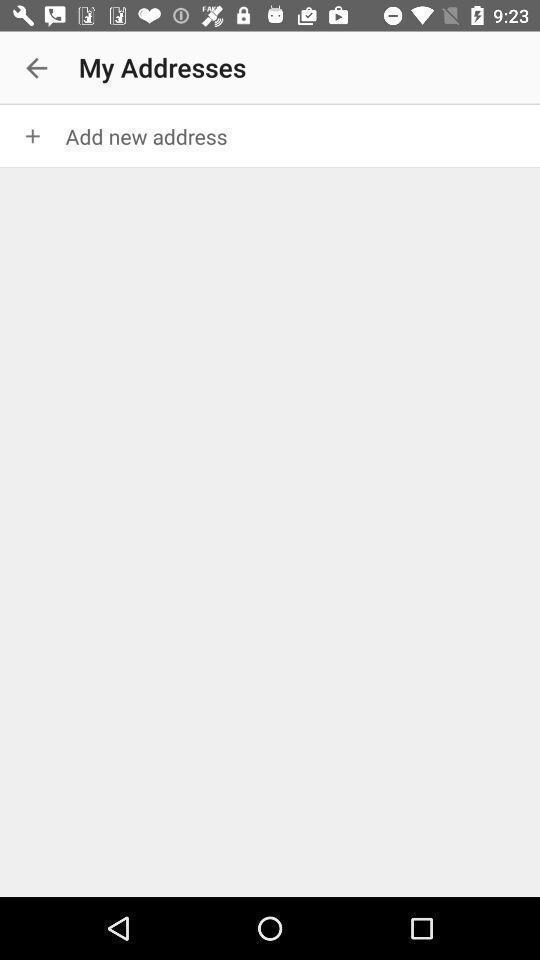Give me a summary of this screen capture. Page showing to add new address. 